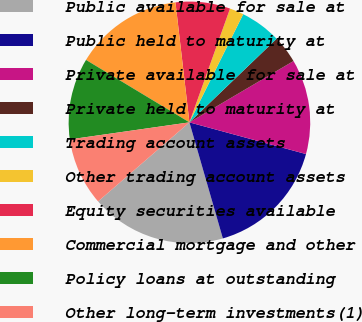Convert chart to OTSL. <chart><loc_0><loc_0><loc_500><loc_500><pie_chart><fcel>Public available for sale at<fcel>Public held to maturity at<fcel>Private available for sale at<fcel>Private held to maturity at<fcel>Trading account assets<fcel>Other trading account assets<fcel>Equity securities available<fcel>Commercial mortgage and other<fcel>Policy loans at outstanding<fcel>Other long-term investments(1)<nl><fcel>18.11%<fcel>16.31%<fcel>12.7%<fcel>3.69%<fcel>5.49%<fcel>1.89%<fcel>7.3%<fcel>14.51%<fcel>10.9%<fcel>9.1%<nl></chart> 